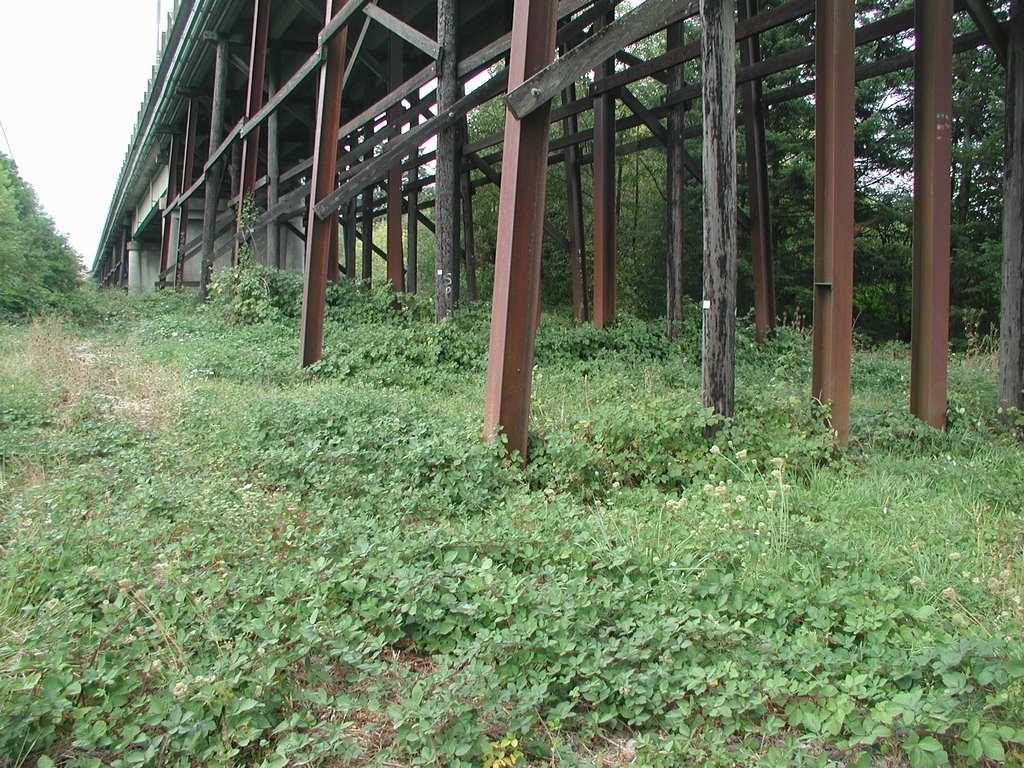What type of living organisms can be seen in the image? Plants and trees are visible in the image. What structures are present in the image? There are poles in the image. What can be seen in the background of the image? The sky is visible in the background of the image. What type of grass is being used to manufacture the drawer in the image? There is no drawer present in the image, and therefore no grass being used for manufacturing. What type of industry is depicted in the image? There is no industry depicted in the image; it features plants, trees, and poles. 